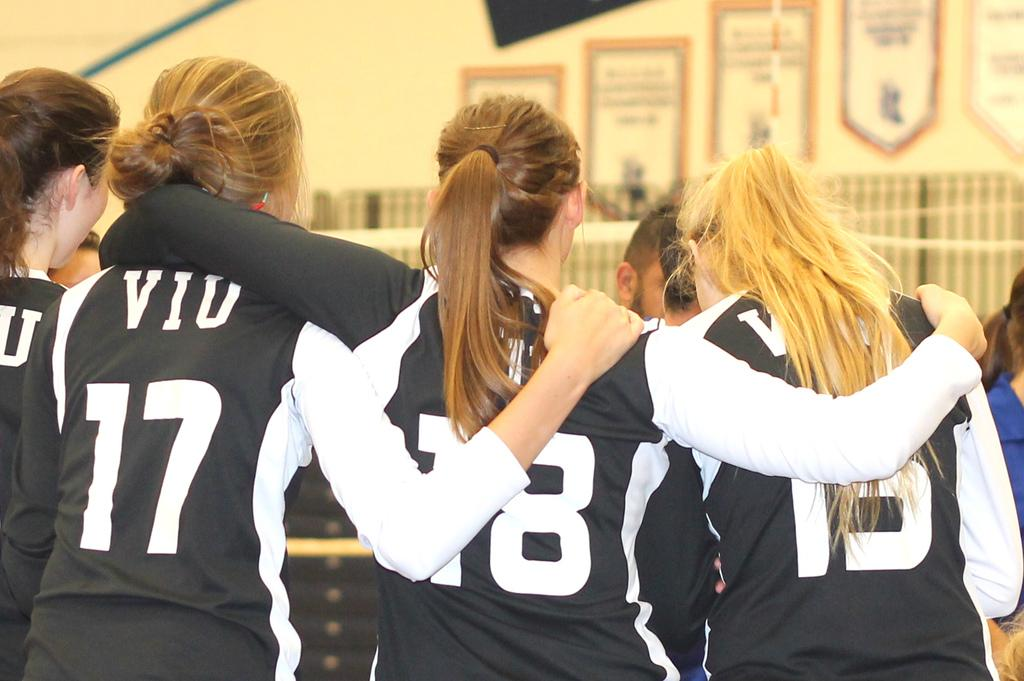How many people are in the image? There are four women in the image. What are the women doing in the image? The women are standing. What are the women wearing in the image? The women are wearing black and white t-shirts. Can you hear the women laughing in the image? There is no sound in the image, so we cannot hear the women laughing. Are the women on a voyage in the image? There is no indication of a voyage or any form of transportation in the image. 